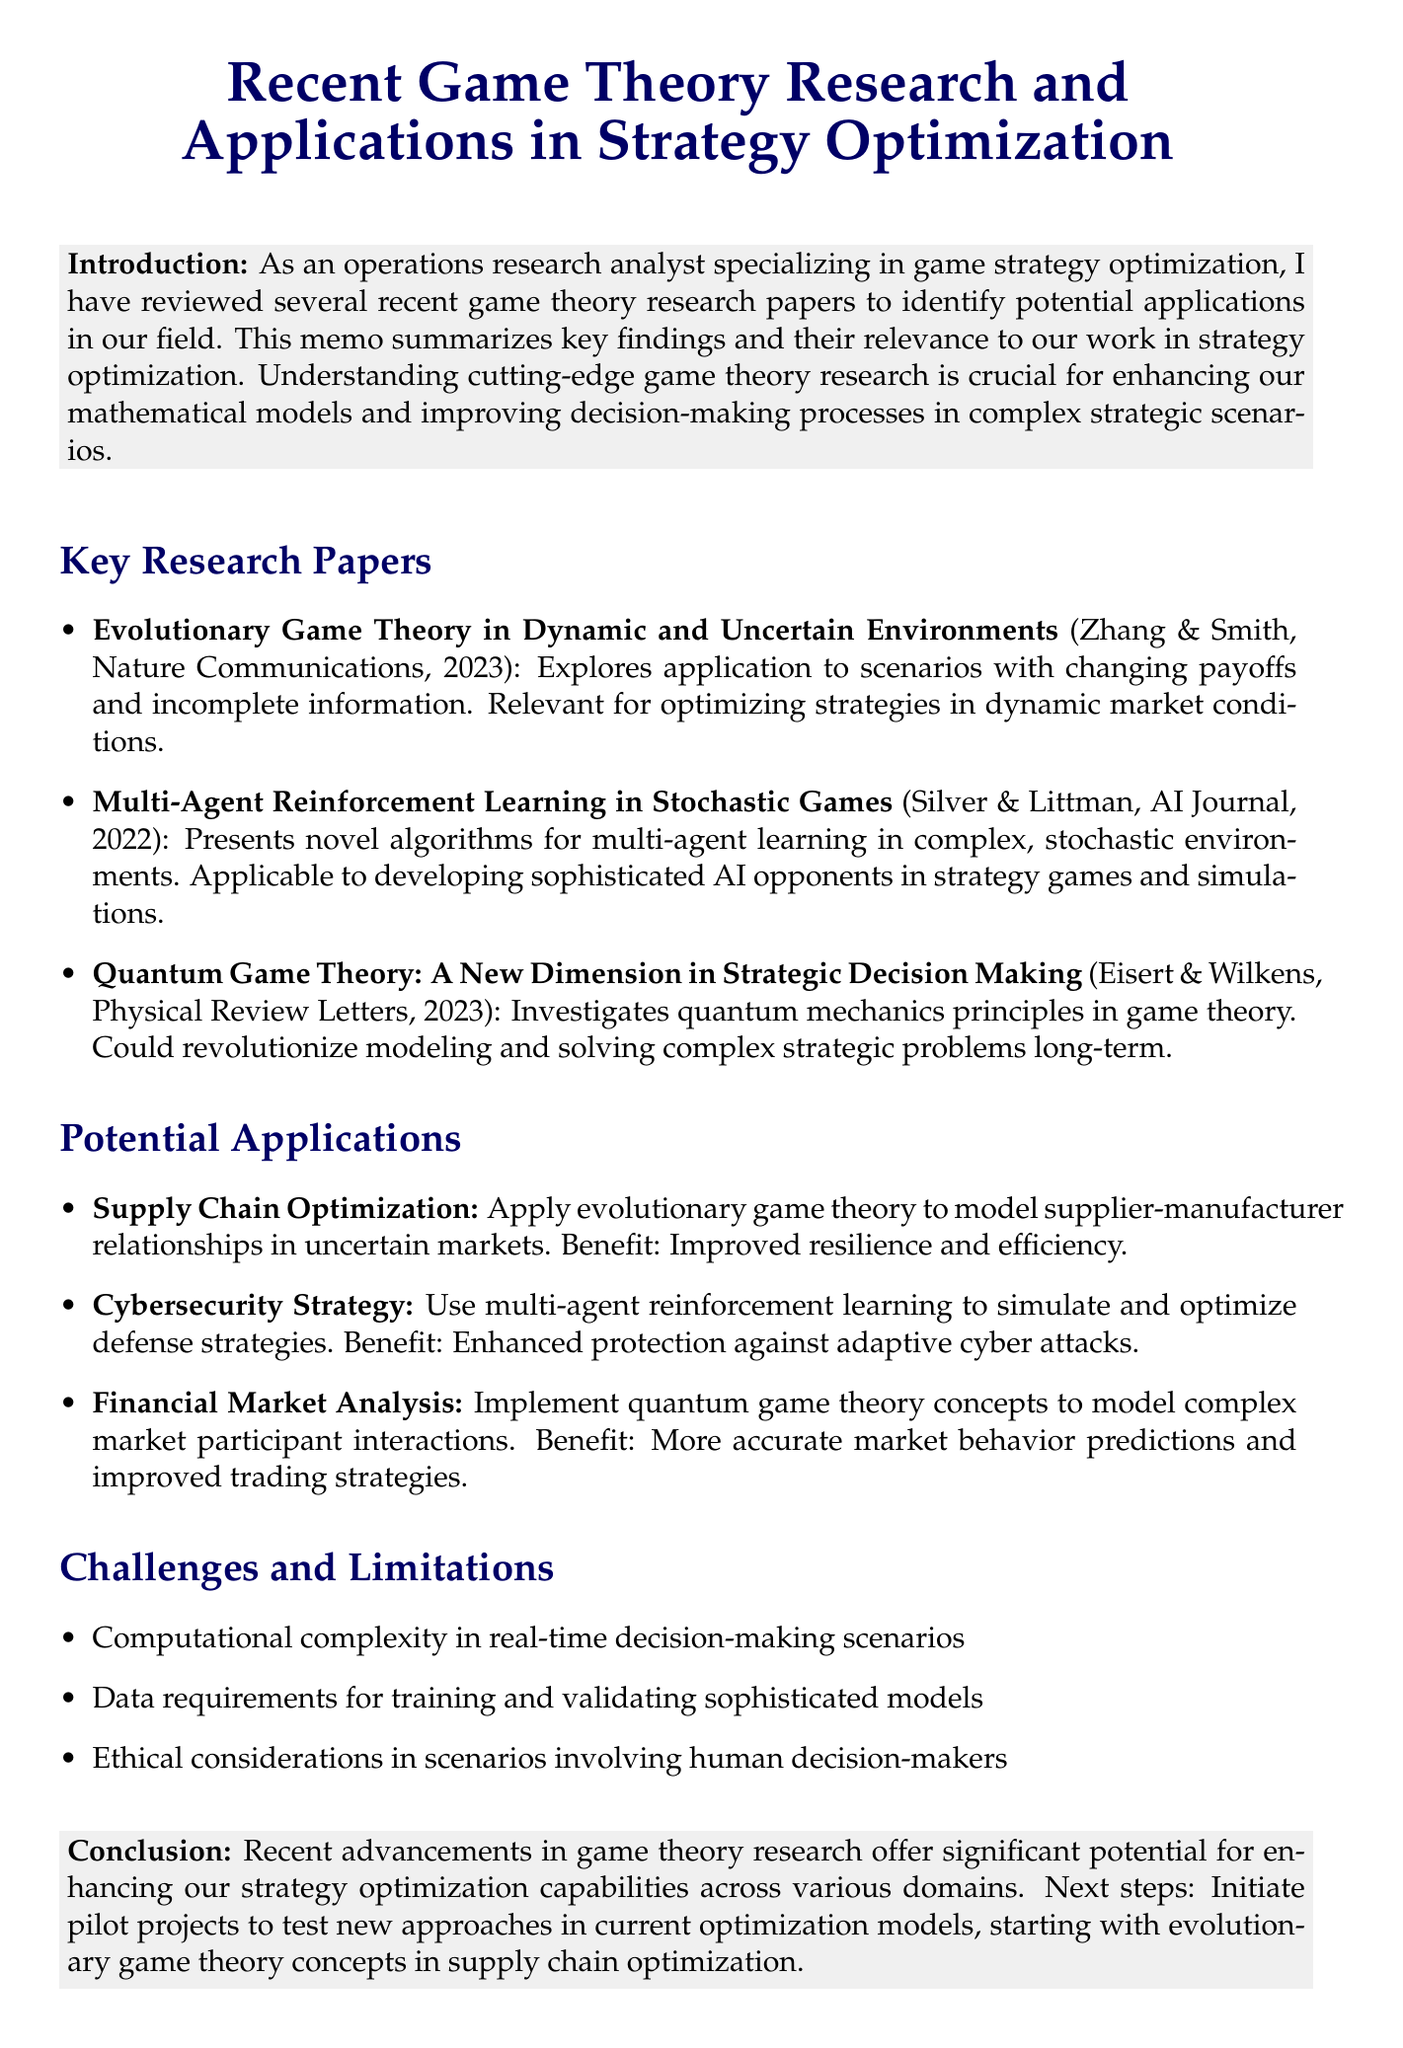What is the title of the memo? The title of the memo summarizing recent game theory research is stated at the beginning of the document.
Answer: Recent Game Theory Research and Applications in Strategy Optimization Who authored the paper on Evolutionary Game Theory? The authors of the paper on Evolutionary Game Theory are listed under the key research papers section.
Answer: Zhang, L., & Smith, J. M In which publication was the multi-agent reinforcement learning paper published? The publication details for the multi-agent reinforcement learning paper can be found in the key research papers section.
Answer: Artificial Intelligence Journal, 2022 What is one potential application of quantum game theory mentioned? The document describes various potential applications of the research, including that of quantum game theory.
Answer: Financial Market Analysis What is a challenge mentioned related to implementing advanced game theory models? The challenges and limitations section lists several issues faced while implementing advanced game theory models.
Answer: Computational complexity What is the recommended next step mentioned in the conclusion? The conclusion section provides specific recommendations for future projects based on research findings.
Answer: Initiating pilot projects How has game theory research recently impacted strategy optimization? The introduction details the significance of recent game theory research for improving decision-making processes.
Answer: Enhancing our strategy optimization capabilities What year was the paper by Eisert and Wilkens published? The publication year for the paper by Eisert and Wilkens is provided in the key research papers section.
Answer: 2023 